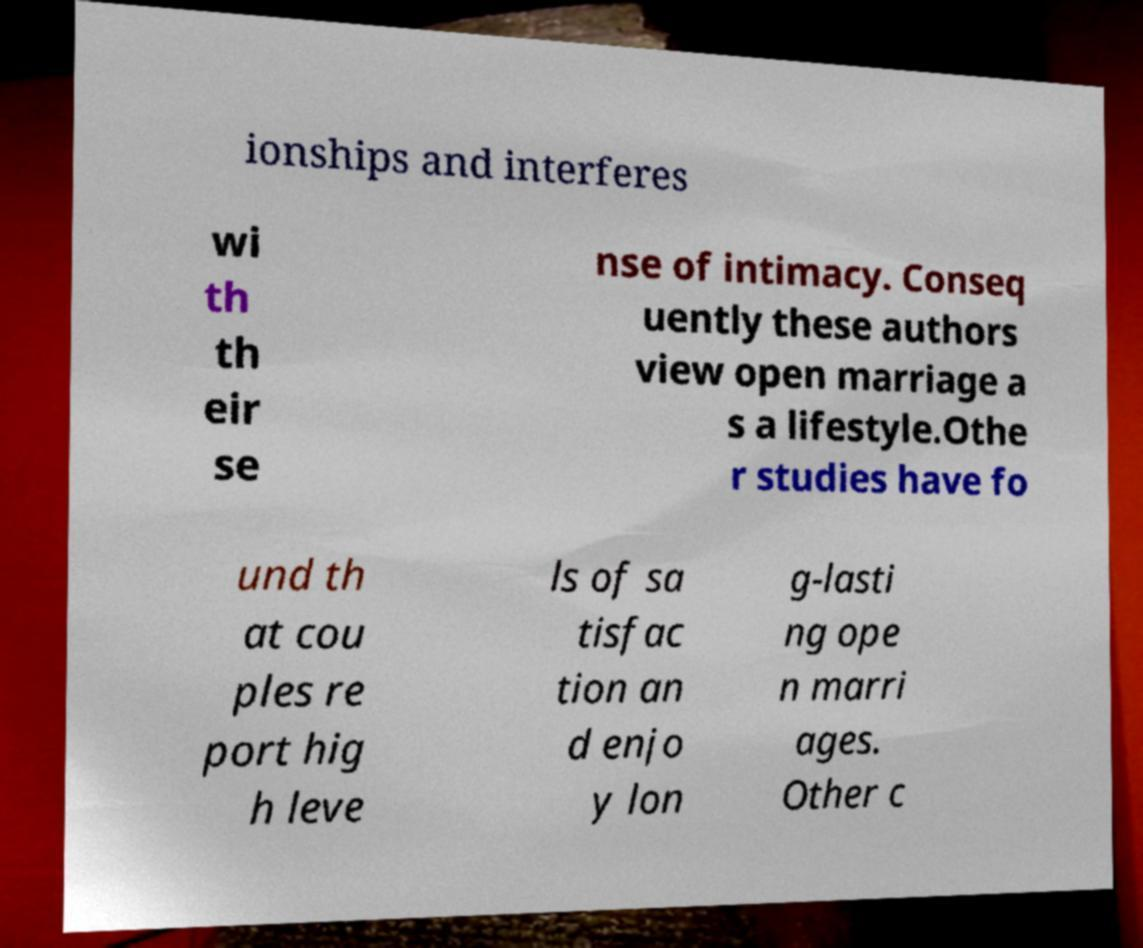There's text embedded in this image that I need extracted. Can you transcribe it verbatim? ionships and interferes wi th th eir se nse of intimacy. Conseq uently these authors view open marriage a s a lifestyle.Othe r studies have fo und th at cou ples re port hig h leve ls of sa tisfac tion an d enjo y lon g-lasti ng ope n marri ages. Other c 